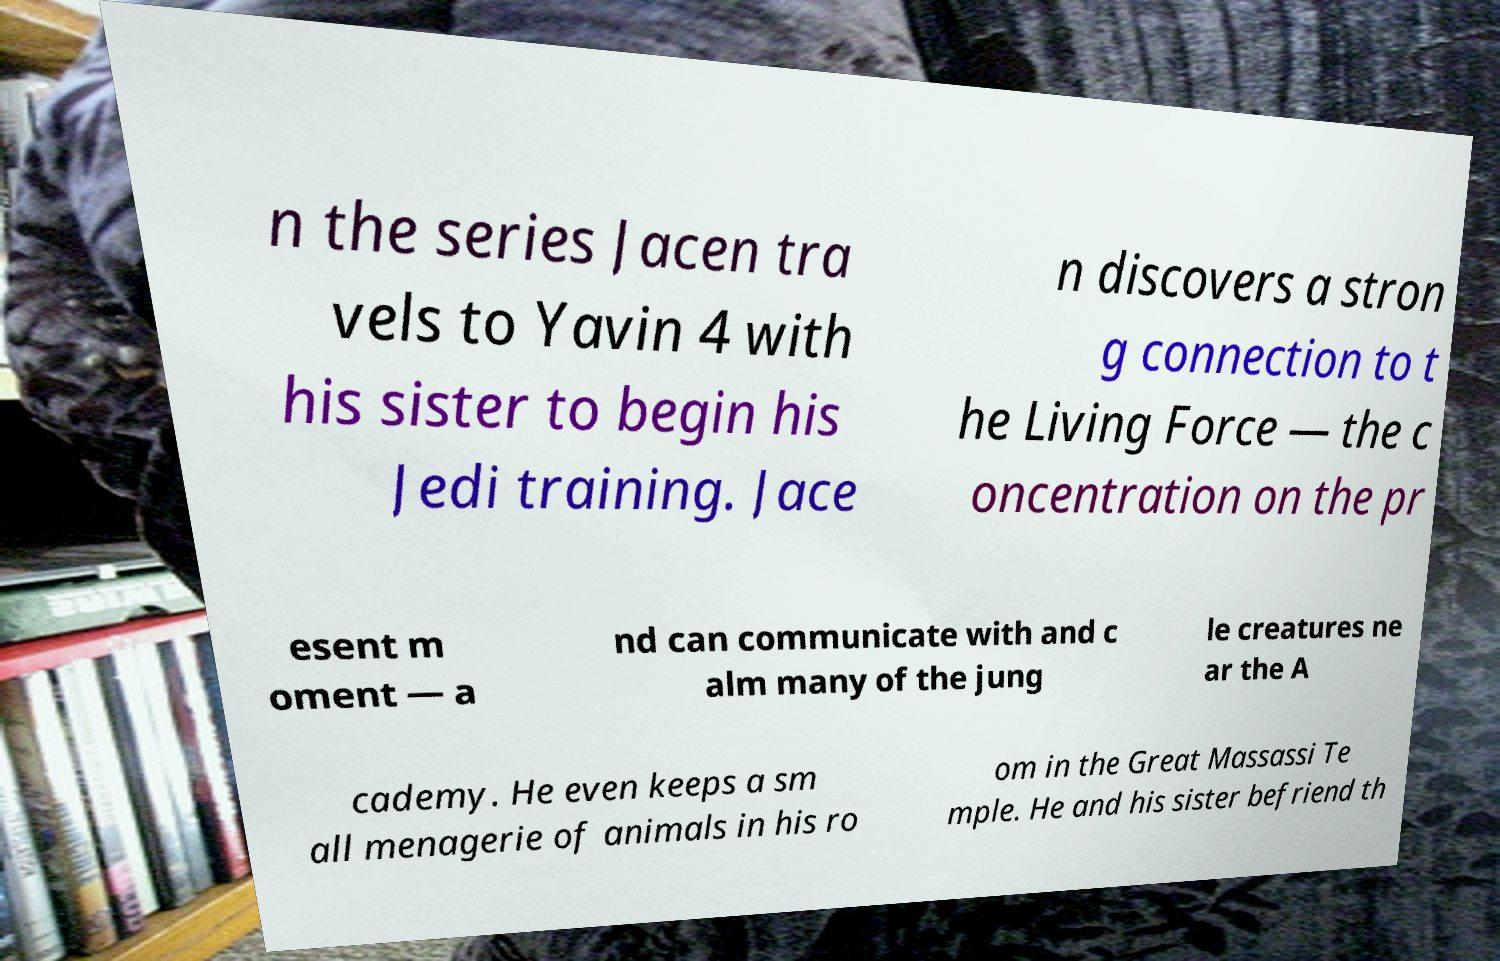Please identify and transcribe the text found in this image. n the series Jacen tra vels to Yavin 4 with his sister to begin his Jedi training. Jace n discovers a stron g connection to t he Living Force — the c oncentration on the pr esent m oment — a nd can communicate with and c alm many of the jung le creatures ne ar the A cademy. He even keeps a sm all menagerie of animals in his ro om in the Great Massassi Te mple. He and his sister befriend th 